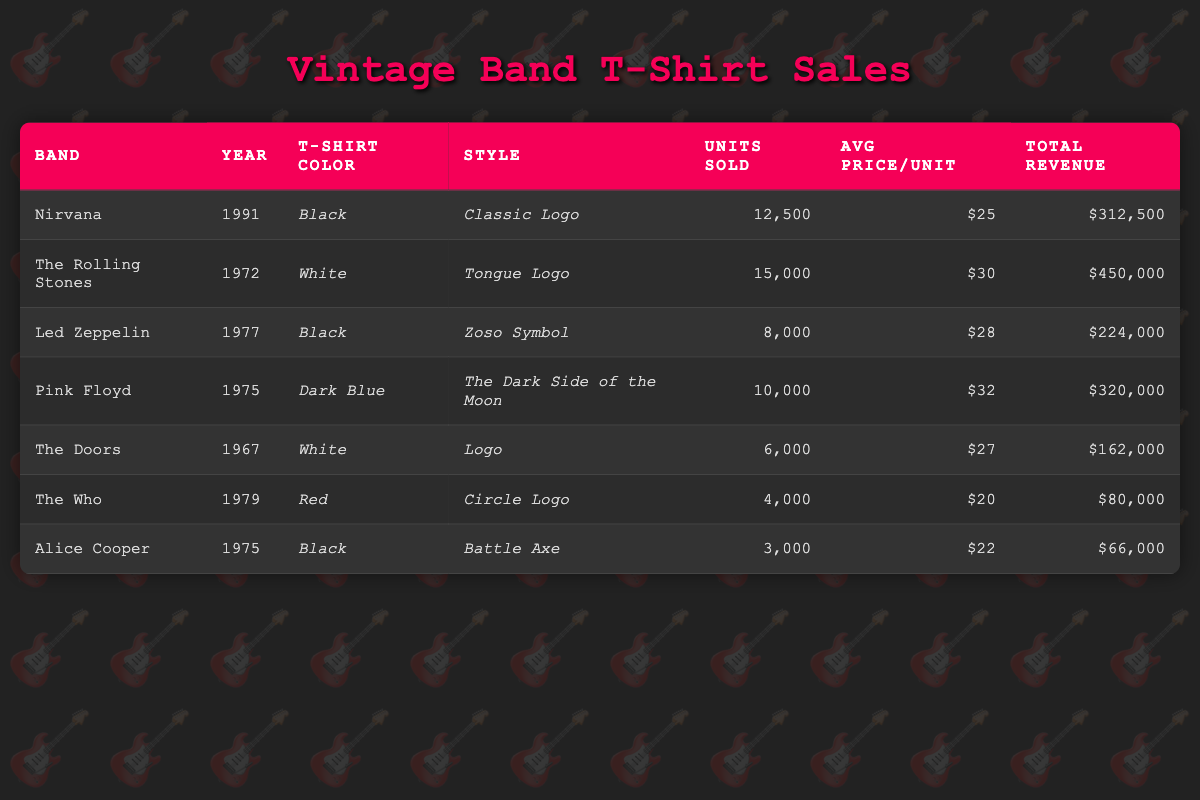What was the total revenue generated by The Rolling Stones t-shirts? The total revenue for The Rolling Stones can be found in the table under the total revenue column for that band, which is $450,000.
Answer: $450,000 Which band sold more units, Nirvana or Pink Floyd? Nirvana sold 12,500 units, while Pink Floyd sold 10,000 units. Comparing these two values, Nirvana sold more units.
Answer: Nirvana What is the average price per unit for t-shirts sold by Led Zeppelin? The average price per unit for Led Zeppelin can be found in the table under the avg price/unit column, which is $28.
Answer: $28 Did Alice Cooper sell more units than The Who? Alice Cooper sold 3,000 units, while The Who sold 4,000 units. Therefore, Alice Cooper did not sell more units than The Who.
Answer: No What is the total revenue from all bands together, rounded to the nearest thousand? To find the total revenue from all bands, we sum up the total revenue for each band: $312,500 + $450,000 + $224,000 + $320,000 + $162,000 + $80,000 + $66,000 = $1,614,500. Rounding this to the nearest thousand gives $1,615,000.
Answer: $1,615,000 Which style generated the highest total revenue, and how much was it? Looking through the total revenue column, we see that The Rolling Stones with the Tongue Logo style generated the highest total revenue at $450,000.
Answer: Tongue Logo, $450,000 How many units were sold in total by bands in the 1970s? We need to sum the units sold for bands that have years in the 1970s: Led Zeppelin (8,000), Pink Floyd (10,000), The Who (4,000), and Alice Cooper (3,000). Adding these gives us 8,000 + 10,000 + 4,000 + 3,000 = 25,000 units sold in total by those bands.
Answer: 25,000 Is the average price per unit for The Doors higher than that of The Who? The average price per unit for The Doors is $27, while for The Who it is $20. Since $27 is greater than $20, the statement is true.
Answer: Yes 